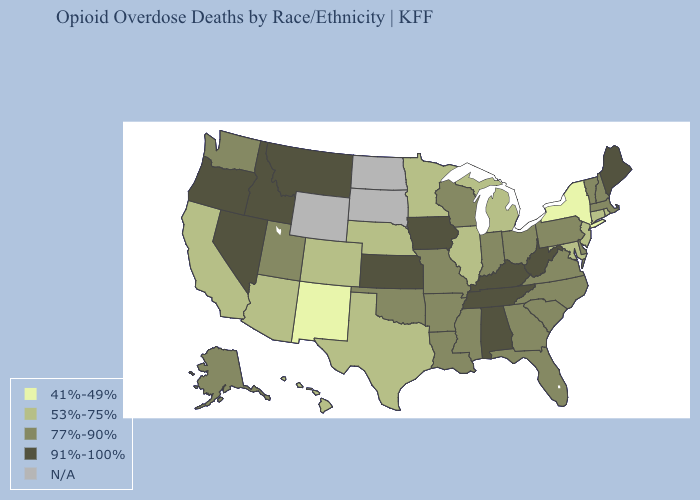Does Kansas have the lowest value in the USA?
Write a very short answer. No. Which states have the lowest value in the USA?
Answer briefly. New Mexico, New York. Among the states that border Georgia , which have the lowest value?
Be succinct. Florida, North Carolina, South Carolina. Does Louisiana have the highest value in the USA?
Quick response, please. No. Among the states that border Kentucky , does West Virginia have the lowest value?
Be succinct. No. Does Kentucky have the highest value in the USA?
Short answer required. Yes. What is the lowest value in the USA?
Be succinct. 41%-49%. Name the states that have a value in the range N/A?
Short answer required. North Dakota, South Dakota, Wyoming. Name the states that have a value in the range 91%-100%?
Short answer required. Alabama, Idaho, Iowa, Kansas, Kentucky, Maine, Montana, Nevada, Oregon, Tennessee, West Virginia. What is the value of Vermont?
Quick response, please. 77%-90%. Name the states that have a value in the range 77%-90%?
Keep it brief. Alaska, Arkansas, Delaware, Florida, Georgia, Indiana, Louisiana, Massachusetts, Mississippi, Missouri, New Hampshire, North Carolina, Ohio, Oklahoma, Pennsylvania, South Carolina, Utah, Vermont, Virginia, Washington, Wisconsin. How many symbols are there in the legend?
Answer briefly. 5. 